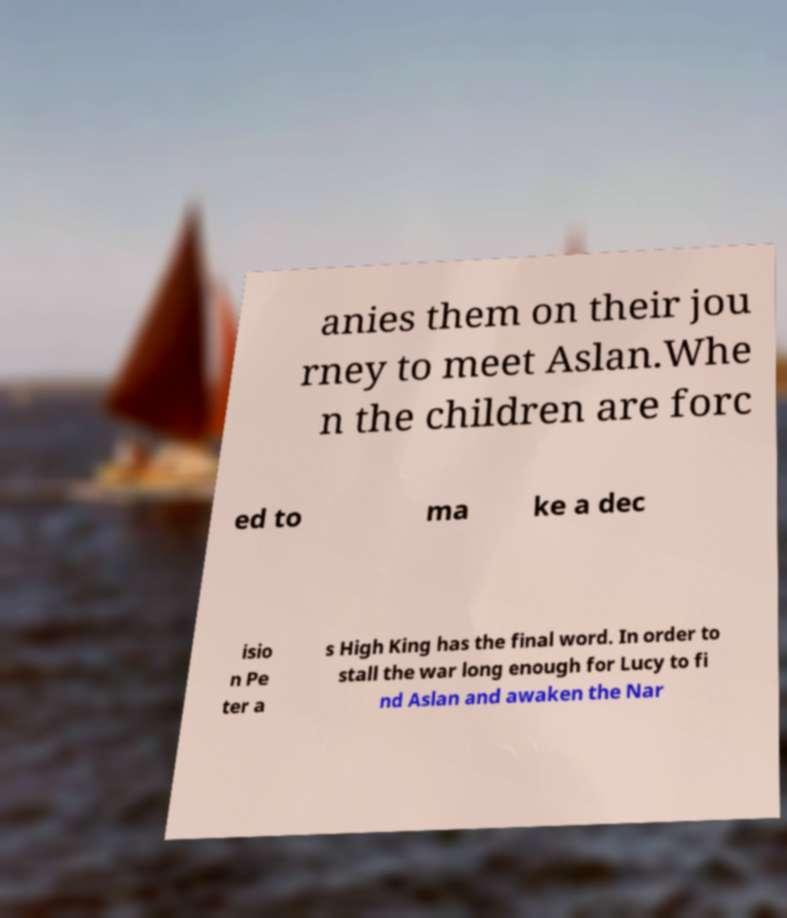Could you extract and type out the text from this image? anies them on their jou rney to meet Aslan.Whe n the children are forc ed to ma ke a dec isio n Pe ter a s High King has the final word. In order to stall the war long enough for Lucy to fi nd Aslan and awaken the Nar 